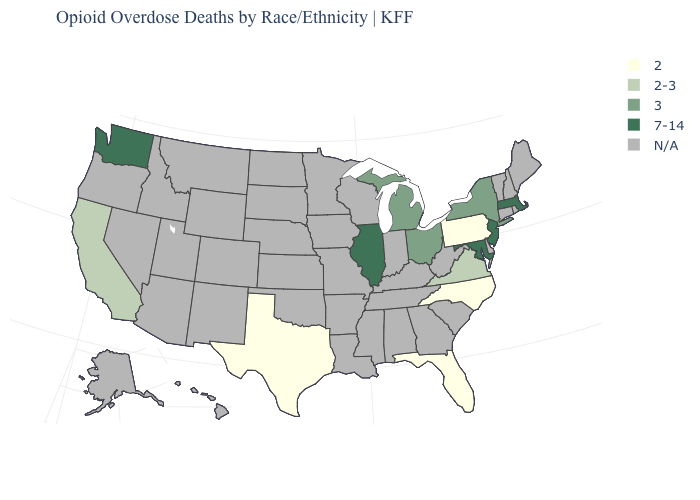What is the value of Rhode Island?
Be succinct. N/A. Name the states that have a value in the range 2-3?
Concise answer only. California, Virginia. Does the first symbol in the legend represent the smallest category?
Keep it brief. Yes. Name the states that have a value in the range 2?
Keep it brief. Florida, North Carolina, Pennsylvania, Texas. What is the value of Utah?
Quick response, please. N/A. Name the states that have a value in the range N/A?
Concise answer only. Alabama, Alaska, Arizona, Arkansas, Colorado, Connecticut, Delaware, Georgia, Hawaii, Idaho, Indiana, Iowa, Kansas, Kentucky, Louisiana, Maine, Minnesota, Mississippi, Missouri, Montana, Nebraska, Nevada, New Hampshire, New Mexico, North Dakota, Oklahoma, Oregon, Rhode Island, South Carolina, South Dakota, Tennessee, Utah, Vermont, West Virginia, Wisconsin, Wyoming. Name the states that have a value in the range N/A?
Answer briefly. Alabama, Alaska, Arizona, Arkansas, Colorado, Connecticut, Delaware, Georgia, Hawaii, Idaho, Indiana, Iowa, Kansas, Kentucky, Louisiana, Maine, Minnesota, Mississippi, Missouri, Montana, Nebraska, Nevada, New Hampshire, New Mexico, North Dakota, Oklahoma, Oregon, Rhode Island, South Carolina, South Dakota, Tennessee, Utah, Vermont, West Virginia, Wisconsin, Wyoming. Which states hav the highest value in the Northeast?
Keep it brief. Massachusetts, New Jersey. Which states hav the highest value in the West?
Concise answer only. Washington. Does Texas have the highest value in the South?
Short answer required. No. Is the legend a continuous bar?
Concise answer only. No. Does Texas have the lowest value in the South?
Write a very short answer. Yes. What is the lowest value in the USA?
Be succinct. 2. 